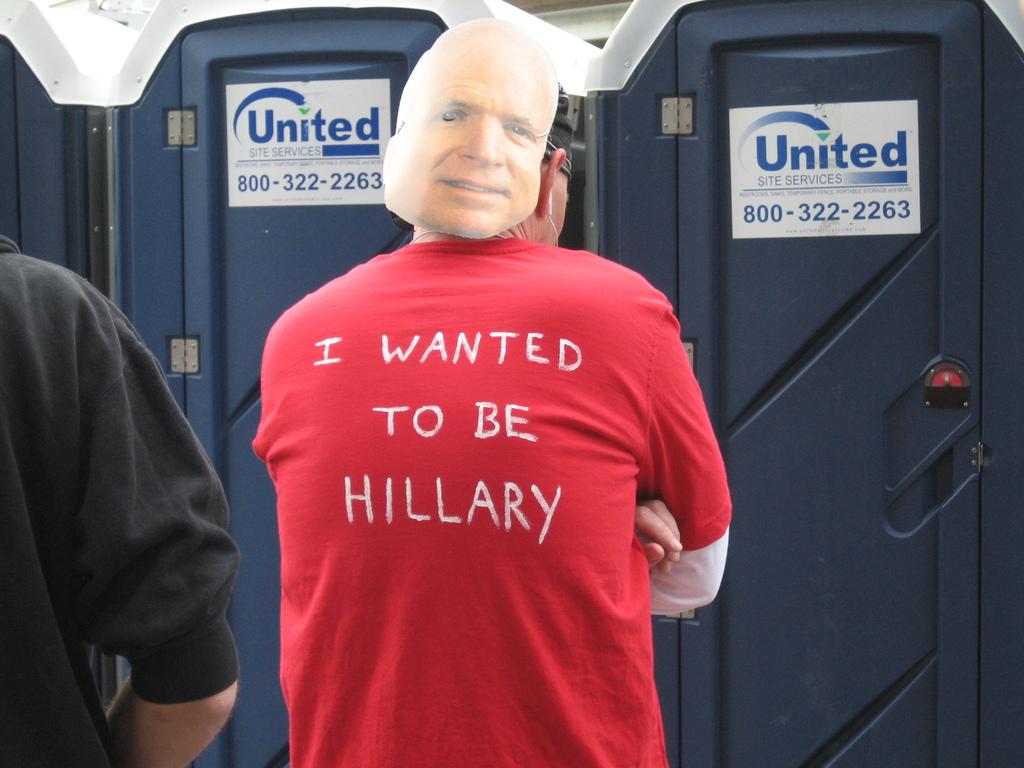What is the phone number on the porta-potties?
Make the answer very short. 800-322-2263. Which company is in charge of the porta-potties?
Provide a short and direct response. United. 